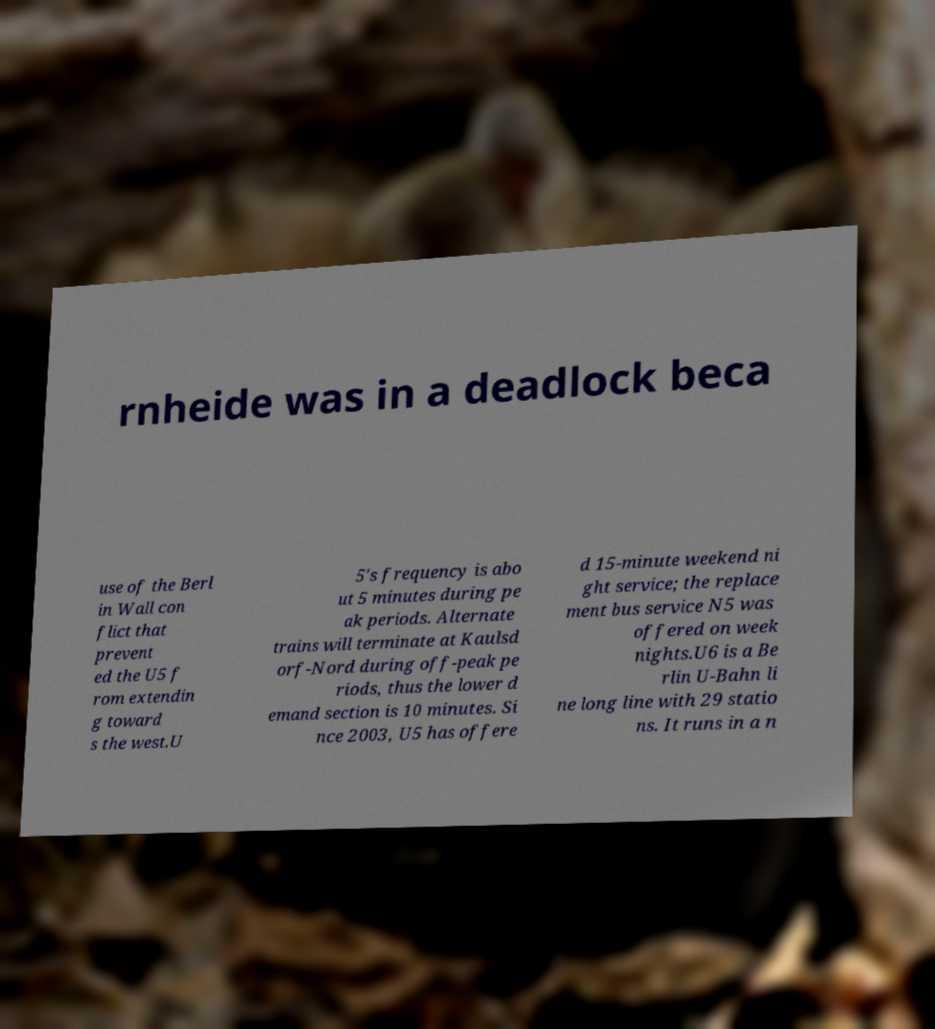I need the written content from this picture converted into text. Can you do that? rnheide was in a deadlock beca use of the Berl in Wall con flict that prevent ed the U5 f rom extendin g toward s the west.U 5's frequency is abo ut 5 minutes during pe ak periods. Alternate trains will terminate at Kaulsd orf-Nord during off-peak pe riods, thus the lower d emand section is 10 minutes. Si nce 2003, U5 has offere d 15-minute weekend ni ght service; the replace ment bus service N5 was offered on week nights.U6 is a Be rlin U-Bahn li ne long line with 29 statio ns. It runs in a n 